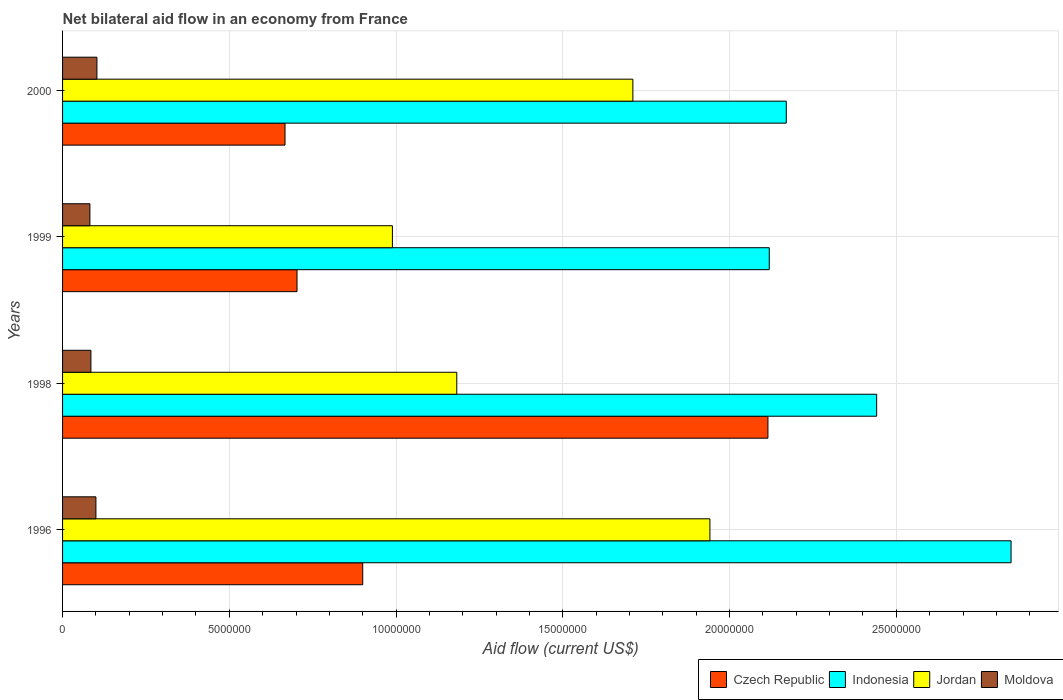How many groups of bars are there?
Provide a short and direct response. 4. Across all years, what is the maximum net bilateral aid flow in Czech Republic?
Offer a terse response. 2.12e+07. Across all years, what is the minimum net bilateral aid flow in Indonesia?
Provide a short and direct response. 2.12e+07. What is the total net bilateral aid flow in Jordan in the graph?
Make the answer very short. 5.82e+07. What is the difference between the net bilateral aid flow in Indonesia in 1996 and that in 1998?
Provide a short and direct response. 4.03e+06. What is the difference between the net bilateral aid flow in Indonesia in 1996 and the net bilateral aid flow in Czech Republic in 1999?
Your answer should be very brief. 2.14e+07. What is the average net bilateral aid flow in Moldova per year?
Your answer should be very brief. 9.25e+05. In the year 2000, what is the difference between the net bilateral aid flow in Czech Republic and net bilateral aid flow in Indonesia?
Your answer should be very brief. -1.50e+07. In how many years, is the net bilateral aid flow in Indonesia greater than 4000000 US$?
Your answer should be very brief. 4. What is the ratio of the net bilateral aid flow in Moldova in 1999 to that in 2000?
Your answer should be very brief. 0.8. What is the difference between the highest and the second highest net bilateral aid flow in Czech Republic?
Offer a terse response. 1.22e+07. What is the difference between the highest and the lowest net bilateral aid flow in Indonesia?
Keep it short and to the point. 7.25e+06. Is the sum of the net bilateral aid flow in Moldova in 1996 and 1998 greater than the maximum net bilateral aid flow in Czech Republic across all years?
Give a very brief answer. No. What does the 4th bar from the top in 1996 represents?
Make the answer very short. Czech Republic. What does the 1st bar from the bottom in 1996 represents?
Provide a short and direct response. Czech Republic. How many bars are there?
Provide a short and direct response. 16. Are all the bars in the graph horizontal?
Give a very brief answer. Yes. Are the values on the major ticks of X-axis written in scientific E-notation?
Make the answer very short. No. Does the graph contain any zero values?
Your answer should be compact. No. How are the legend labels stacked?
Offer a terse response. Horizontal. What is the title of the graph?
Your response must be concise. Net bilateral aid flow in an economy from France. Does "Zambia" appear as one of the legend labels in the graph?
Provide a short and direct response. No. What is the label or title of the Y-axis?
Give a very brief answer. Years. What is the Aid flow (current US$) of Czech Republic in 1996?
Provide a short and direct response. 9.00e+06. What is the Aid flow (current US$) in Indonesia in 1996?
Ensure brevity in your answer.  2.84e+07. What is the Aid flow (current US$) in Jordan in 1996?
Your answer should be compact. 1.94e+07. What is the Aid flow (current US$) of Czech Republic in 1998?
Keep it short and to the point. 2.12e+07. What is the Aid flow (current US$) in Indonesia in 1998?
Give a very brief answer. 2.44e+07. What is the Aid flow (current US$) in Jordan in 1998?
Ensure brevity in your answer.  1.18e+07. What is the Aid flow (current US$) of Moldova in 1998?
Your answer should be compact. 8.50e+05. What is the Aid flow (current US$) of Czech Republic in 1999?
Your answer should be very brief. 7.03e+06. What is the Aid flow (current US$) of Indonesia in 1999?
Your answer should be compact. 2.12e+07. What is the Aid flow (current US$) of Jordan in 1999?
Your answer should be very brief. 9.89e+06. What is the Aid flow (current US$) of Moldova in 1999?
Provide a succinct answer. 8.20e+05. What is the Aid flow (current US$) of Czech Republic in 2000?
Your answer should be compact. 6.67e+06. What is the Aid flow (current US$) in Indonesia in 2000?
Your response must be concise. 2.17e+07. What is the Aid flow (current US$) of Jordan in 2000?
Your response must be concise. 1.71e+07. What is the Aid flow (current US$) of Moldova in 2000?
Make the answer very short. 1.03e+06. Across all years, what is the maximum Aid flow (current US$) in Czech Republic?
Provide a succinct answer. 2.12e+07. Across all years, what is the maximum Aid flow (current US$) of Indonesia?
Offer a very short reply. 2.84e+07. Across all years, what is the maximum Aid flow (current US$) in Jordan?
Ensure brevity in your answer.  1.94e+07. Across all years, what is the maximum Aid flow (current US$) of Moldova?
Ensure brevity in your answer.  1.03e+06. Across all years, what is the minimum Aid flow (current US$) of Czech Republic?
Make the answer very short. 6.67e+06. Across all years, what is the minimum Aid flow (current US$) in Indonesia?
Offer a terse response. 2.12e+07. Across all years, what is the minimum Aid flow (current US$) of Jordan?
Make the answer very short. 9.89e+06. Across all years, what is the minimum Aid flow (current US$) of Moldova?
Offer a very short reply. 8.20e+05. What is the total Aid flow (current US$) in Czech Republic in the graph?
Provide a succinct answer. 4.38e+07. What is the total Aid flow (current US$) of Indonesia in the graph?
Make the answer very short. 9.57e+07. What is the total Aid flow (current US$) in Jordan in the graph?
Ensure brevity in your answer.  5.82e+07. What is the total Aid flow (current US$) in Moldova in the graph?
Your answer should be compact. 3.70e+06. What is the difference between the Aid flow (current US$) in Czech Republic in 1996 and that in 1998?
Offer a terse response. -1.22e+07. What is the difference between the Aid flow (current US$) in Indonesia in 1996 and that in 1998?
Your answer should be very brief. 4.03e+06. What is the difference between the Aid flow (current US$) of Jordan in 1996 and that in 1998?
Your answer should be very brief. 7.59e+06. What is the difference between the Aid flow (current US$) of Czech Republic in 1996 and that in 1999?
Make the answer very short. 1.97e+06. What is the difference between the Aid flow (current US$) of Indonesia in 1996 and that in 1999?
Ensure brevity in your answer.  7.25e+06. What is the difference between the Aid flow (current US$) in Jordan in 1996 and that in 1999?
Provide a succinct answer. 9.52e+06. What is the difference between the Aid flow (current US$) in Czech Republic in 1996 and that in 2000?
Offer a terse response. 2.33e+06. What is the difference between the Aid flow (current US$) of Indonesia in 1996 and that in 2000?
Keep it short and to the point. 6.74e+06. What is the difference between the Aid flow (current US$) of Jordan in 1996 and that in 2000?
Keep it short and to the point. 2.31e+06. What is the difference between the Aid flow (current US$) of Czech Republic in 1998 and that in 1999?
Give a very brief answer. 1.41e+07. What is the difference between the Aid flow (current US$) of Indonesia in 1998 and that in 1999?
Keep it short and to the point. 3.22e+06. What is the difference between the Aid flow (current US$) of Jordan in 1998 and that in 1999?
Your response must be concise. 1.93e+06. What is the difference between the Aid flow (current US$) of Czech Republic in 1998 and that in 2000?
Provide a succinct answer. 1.45e+07. What is the difference between the Aid flow (current US$) in Indonesia in 1998 and that in 2000?
Make the answer very short. 2.71e+06. What is the difference between the Aid flow (current US$) in Jordan in 1998 and that in 2000?
Give a very brief answer. -5.28e+06. What is the difference between the Aid flow (current US$) of Moldova in 1998 and that in 2000?
Ensure brevity in your answer.  -1.80e+05. What is the difference between the Aid flow (current US$) of Indonesia in 1999 and that in 2000?
Your answer should be compact. -5.10e+05. What is the difference between the Aid flow (current US$) of Jordan in 1999 and that in 2000?
Provide a short and direct response. -7.21e+06. What is the difference between the Aid flow (current US$) of Moldova in 1999 and that in 2000?
Your answer should be very brief. -2.10e+05. What is the difference between the Aid flow (current US$) of Czech Republic in 1996 and the Aid flow (current US$) of Indonesia in 1998?
Give a very brief answer. -1.54e+07. What is the difference between the Aid flow (current US$) of Czech Republic in 1996 and the Aid flow (current US$) of Jordan in 1998?
Provide a short and direct response. -2.82e+06. What is the difference between the Aid flow (current US$) in Czech Republic in 1996 and the Aid flow (current US$) in Moldova in 1998?
Provide a succinct answer. 8.15e+06. What is the difference between the Aid flow (current US$) in Indonesia in 1996 and the Aid flow (current US$) in Jordan in 1998?
Offer a terse response. 1.66e+07. What is the difference between the Aid flow (current US$) in Indonesia in 1996 and the Aid flow (current US$) in Moldova in 1998?
Keep it short and to the point. 2.76e+07. What is the difference between the Aid flow (current US$) of Jordan in 1996 and the Aid flow (current US$) of Moldova in 1998?
Provide a short and direct response. 1.86e+07. What is the difference between the Aid flow (current US$) of Czech Republic in 1996 and the Aid flow (current US$) of Indonesia in 1999?
Your answer should be compact. -1.22e+07. What is the difference between the Aid flow (current US$) of Czech Republic in 1996 and the Aid flow (current US$) of Jordan in 1999?
Ensure brevity in your answer.  -8.90e+05. What is the difference between the Aid flow (current US$) of Czech Republic in 1996 and the Aid flow (current US$) of Moldova in 1999?
Ensure brevity in your answer.  8.18e+06. What is the difference between the Aid flow (current US$) in Indonesia in 1996 and the Aid flow (current US$) in Jordan in 1999?
Keep it short and to the point. 1.86e+07. What is the difference between the Aid flow (current US$) in Indonesia in 1996 and the Aid flow (current US$) in Moldova in 1999?
Your answer should be very brief. 2.76e+07. What is the difference between the Aid flow (current US$) of Jordan in 1996 and the Aid flow (current US$) of Moldova in 1999?
Your response must be concise. 1.86e+07. What is the difference between the Aid flow (current US$) of Czech Republic in 1996 and the Aid flow (current US$) of Indonesia in 2000?
Keep it short and to the point. -1.27e+07. What is the difference between the Aid flow (current US$) in Czech Republic in 1996 and the Aid flow (current US$) in Jordan in 2000?
Provide a succinct answer. -8.10e+06. What is the difference between the Aid flow (current US$) of Czech Republic in 1996 and the Aid flow (current US$) of Moldova in 2000?
Provide a short and direct response. 7.97e+06. What is the difference between the Aid flow (current US$) of Indonesia in 1996 and the Aid flow (current US$) of Jordan in 2000?
Keep it short and to the point. 1.13e+07. What is the difference between the Aid flow (current US$) in Indonesia in 1996 and the Aid flow (current US$) in Moldova in 2000?
Provide a short and direct response. 2.74e+07. What is the difference between the Aid flow (current US$) of Jordan in 1996 and the Aid flow (current US$) of Moldova in 2000?
Give a very brief answer. 1.84e+07. What is the difference between the Aid flow (current US$) in Czech Republic in 1998 and the Aid flow (current US$) in Indonesia in 1999?
Offer a very short reply. -4.00e+04. What is the difference between the Aid flow (current US$) of Czech Republic in 1998 and the Aid flow (current US$) of Jordan in 1999?
Give a very brief answer. 1.13e+07. What is the difference between the Aid flow (current US$) of Czech Republic in 1998 and the Aid flow (current US$) of Moldova in 1999?
Your answer should be compact. 2.03e+07. What is the difference between the Aid flow (current US$) in Indonesia in 1998 and the Aid flow (current US$) in Jordan in 1999?
Your answer should be compact. 1.45e+07. What is the difference between the Aid flow (current US$) of Indonesia in 1998 and the Aid flow (current US$) of Moldova in 1999?
Your answer should be compact. 2.36e+07. What is the difference between the Aid flow (current US$) in Jordan in 1998 and the Aid flow (current US$) in Moldova in 1999?
Make the answer very short. 1.10e+07. What is the difference between the Aid flow (current US$) of Czech Republic in 1998 and the Aid flow (current US$) of Indonesia in 2000?
Your response must be concise. -5.50e+05. What is the difference between the Aid flow (current US$) in Czech Republic in 1998 and the Aid flow (current US$) in Jordan in 2000?
Your answer should be very brief. 4.05e+06. What is the difference between the Aid flow (current US$) of Czech Republic in 1998 and the Aid flow (current US$) of Moldova in 2000?
Your answer should be compact. 2.01e+07. What is the difference between the Aid flow (current US$) in Indonesia in 1998 and the Aid flow (current US$) in Jordan in 2000?
Your response must be concise. 7.31e+06. What is the difference between the Aid flow (current US$) of Indonesia in 1998 and the Aid flow (current US$) of Moldova in 2000?
Your answer should be very brief. 2.34e+07. What is the difference between the Aid flow (current US$) of Jordan in 1998 and the Aid flow (current US$) of Moldova in 2000?
Provide a short and direct response. 1.08e+07. What is the difference between the Aid flow (current US$) in Czech Republic in 1999 and the Aid flow (current US$) in Indonesia in 2000?
Provide a succinct answer. -1.47e+07. What is the difference between the Aid flow (current US$) of Czech Republic in 1999 and the Aid flow (current US$) of Jordan in 2000?
Make the answer very short. -1.01e+07. What is the difference between the Aid flow (current US$) of Indonesia in 1999 and the Aid flow (current US$) of Jordan in 2000?
Make the answer very short. 4.09e+06. What is the difference between the Aid flow (current US$) of Indonesia in 1999 and the Aid flow (current US$) of Moldova in 2000?
Make the answer very short. 2.02e+07. What is the difference between the Aid flow (current US$) in Jordan in 1999 and the Aid flow (current US$) in Moldova in 2000?
Offer a very short reply. 8.86e+06. What is the average Aid flow (current US$) in Czech Republic per year?
Your answer should be compact. 1.10e+07. What is the average Aid flow (current US$) of Indonesia per year?
Your answer should be compact. 2.39e+07. What is the average Aid flow (current US$) in Jordan per year?
Provide a short and direct response. 1.46e+07. What is the average Aid flow (current US$) of Moldova per year?
Your answer should be very brief. 9.25e+05. In the year 1996, what is the difference between the Aid flow (current US$) of Czech Republic and Aid flow (current US$) of Indonesia?
Your answer should be compact. -1.94e+07. In the year 1996, what is the difference between the Aid flow (current US$) in Czech Republic and Aid flow (current US$) in Jordan?
Provide a succinct answer. -1.04e+07. In the year 1996, what is the difference between the Aid flow (current US$) of Indonesia and Aid flow (current US$) of Jordan?
Offer a very short reply. 9.03e+06. In the year 1996, what is the difference between the Aid flow (current US$) in Indonesia and Aid flow (current US$) in Moldova?
Ensure brevity in your answer.  2.74e+07. In the year 1996, what is the difference between the Aid flow (current US$) of Jordan and Aid flow (current US$) of Moldova?
Keep it short and to the point. 1.84e+07. In the year 1998, what is the difference between the Aid flow (current US$) of Czech Republic and Aid flow (current US$) of Indonesia?
Keep it short and to the point. -3.26e+06. In the year 1998, what is the difference between the Aid flow (current US$) of Czech Republic and Aid flow (current US$) of Jordan?
Provide a short and direct response. 9.33e+06. In the year 1998, what is the difference between the Aid flow (current US$) of Czech Republic and Aid flow (current US$) of Moldova?
Offer a terse response. 2.03e+07. In the year 1998, what is the difference between the Aid flow (current US$) in Indonesia and Aid flow (current US$) in Jordan?
Your answer should be compact. 1.26e+07. In the year 1998, what is the difference between the Aid flow (current US$) in Indonesia and Aid flow (current US$) in Moldova?
Your response must be concise. 2.36e+07. In the year 1998, what is the difference between the Aid flow (current US$) in Jordan and Aid flow (current US$) in Moldova?
Provide a short and direct response. 1.10e+07. In the year 1999, what is the difference between the Aid flow (current US$) in Czech Republic and Aid flow (current US$) in Indonesia?
Offer a very short reply. -1.42e+07. In the year 1999, what is the difference between the Aid flow (current US$) of Czech Republic and Aid flow (current US$) of Jordan?
Your response must be concise. -2.86e+06. In the year 1999, what is the difference between the Aid flow (current US$) of Czech Republic and Aid flow (current US$) of Moldova?
Keep it short and to the point. 6.21e+06. In the year 1999, what is the difference between the Aid flow (current US$) of Indonesia and Aid flow (current US$) of Jordan?
Your answer should be very brief. 1.13e+07. In the year 1999, what is the difference between the Aid flow (current US$) of Indonesia and Aid flow (current US$) of Moldova?
Make the answer very short. 2.04e+07. In the year 1999, what is the difference between the Aid flow (current US$) of Jordan and Aid flow (current US$) of Moldova?
Provide a short and direct response. 9.07e+06. In the year 2000, what is the difference between the Aid flow (current US$) of Czech Republic and Aid flow (current US$) of Indonesia?
Keep it short and to the point. -1.50e+07. In the year 2000, what is the difference between the Aid flow (current US$) in Czech Republic and Aid flow (current US$) in Jordan?
Your answer should be compact. -1.04e+07. In the year 2000, what is the difference between the Aid flow (current US$) of Czech Republic and Aid flow (current US$) of Moldova?
Your answer should be very brief. 5.64e+06. In the year 2000, what is the difference between the Aid flow (current US$) in Indonesia and Aid flow (current US$) in Jordan?
Your answer should be compact. 4.60e+06. In the year 2000, what is the difference between the Aid flow (current US$) of Indonesia and Aid flow (current US$) of Moldova?
Provide a succinct answer. 2.07e+07. In the year 2000, what is the difference between the Aid flow (current US$) in Jordan and Aid flow (current US$) in Moldova?
Your answer should be compact. 1.61e+07. What is the ratio of the Aid flow (current US$) in Czech Republic in 1996 to that in 1998?
Your answer should be compact. 0.43. What is the ratio of the Aid flow (current US$) of Indonesia in 1996 to that in 1998?
Provide a succinct answer. 1.17. What is the ratio of the Aid flow (current US$) of Jordan in 1996 to that in 1998?
Ensure brevity in your answer.  1.64. What is the ratio of the Aid flow (current US$) in Moldova in 1996 to that in 1998?
Provide a succinct answer. 1.18. What is the ratio of the Aid flow (current US$) in Czech Republic in 1996 to that in 1999?
Your answer should be very brief. 1.28. What is the ratio of the Aid flow (current US$) of Indonesia in 1996 to that in 1999?
Offer a very short reply. 1.34. What is the ratio of the Aid flow (current US$) in Jordan in 1996 to that in 1999?
Keep it short and to the point. 1.96. What is the ratio of the Aid flow (current US$) in Moldova in 1996 to that in 1999?
Your answer should be compact. 1.22. What is the ratio of the Aid flow (current US$) of Czech Republic in 1996 to that in 2000?
Give a very brief answer. 1.35. What is the ratio of the Aid flow (current US$) of Indonesia in 1996 to that in 2000?
Make the answer very short. 1.31. What is the ratio of the Aid flow (current US$) in Jordan in 1996 to that in 2000?
Offer a terse response. 1.14. What is the ratio of the Aid flow (current US$) of Moldova in 1996 to that in 2000?
Keep it short and to the point. 0.97. What is the ratio of the Aid flow (current US$) in Czech Republic in 1998 to that in 1999?
Give a very brief answer. 3.01. What is the ratio of the Aid flow (current US$) in Indonesia in 1998 to that in 1999?
Provide a short and direct response. 1.15. What is the ratio of the Aid flow (current US$) in Jordan in 1998 to that in 1999?
Keep it short and to the point. 1.2. What is the ratio of the Aid flow (current US$) in Moldova in 1998 to that in 1999?
Your answer should be very brief. 1.04. What is the ratio of the Aid flow (current US$) of Czech Republic in 1998 to that in 2000?
Your answer should be compact. 3.17. What is the ratio of the Aid flow (current US$) of Indonesia in 1998 to that in 2000?
Keep it short and to the point. 1.12. What is the ratio of the Aid flow (current US$) in Jordan in 1998 to that in 2000?
Give a very brief answer. 0.69. What is the ratio of the Aid flow (current US$) in Moldova in 1998 to that in 2000?
Give a very brief answer. 0.83. What is the ratio of the Aid flow (current US$) in Czech Republic in 1999 to that in 2000?
Provide a short and direct response. 1.05. What is the ratio of the Aid flow (current US$) in Indonesia in 1999 to that in 2000?
Your answer should be very brief. 0.98. What is the ratio of the Aid flow (current US$) of Jordan in 1999 to that in 2000?
Your answer should be compact. 0.58. What is the ratio of the Aid flow (current US$) of Moldova in 1999 to that in 2000?
Your answer should be compact. 0.8. What is the difference between the highest and the second highest Aid flow (current US$) of Czech Republic?
Keep it short and to the point. 1.22e+07. What is the difference between the highest and the second highest Aid flow (current US$) of Indonesia?
Your answer should be very brief. 4.03e+06. What is the difference between the highest and the second highest Aid flow (current US$) of Jordan?
Your response must be concise. 2.31e+06. What is the difference between the highest and the second highest Aid flow (current US$) in Moldova?
Keep it short and to the point. 3.00e+04. What is the difference between the highest and the lowest Aid flow (current US$) in Czech Republic?
Give a very brief answer. 1.45e+07. What is the difference between the highest and the lowest Aid flow (current US$) in Indonesia?
Your answer should be very brief. 7.25e+06. What is the difference between the highest and the lowest Aid flow (current US$) in Jordan?
Your answer should be very brief. 9.52e+06. 